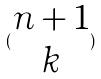Convert formula to latex. <formula><loc_0><loc_0><loc_500><loc_500>( \begin{matrix} n + 1 \\ k \end{matrix} )</formula> 